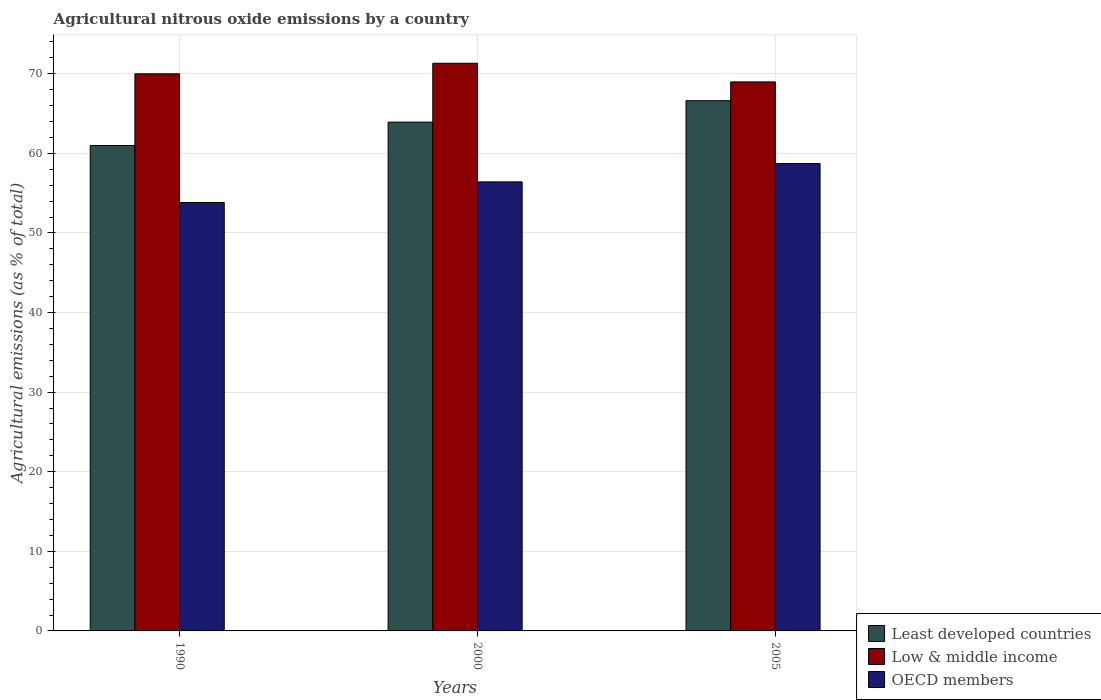How many groups of bars are there?
Ensure brevity in your answer.  3. Are the number of bars on each tick of the X-axis equal?
Keep it short and to the point. Yes. How many bars are there on the 2nd tick from the right?
Ensure brevity in your answer.  3. What is the label of the 2nd group of bars from the left?
Your answer should be compact. 2000. What is the amount of agricultural nitrous oxide emitted in Least developed countries in 1990?
Your answer should be compact. 60.99. Across all years, what is the maximum amount of agricultural nitrous oxide emitted in OECD members?
Offer a terse response. 58.73. Across all years, what is the minimum amount of agricultural nitrous oxide emitted in OECD members?
Provide a short and direct response. 53.83. What is the total amount of agricultural nitrous oxide emitted in OECD members in the graph?
Provide a short and direct response. 168.98. What is the difference between the amount of agricultural nitrous oxide emitted in Least developed countries in 1990 and that in 2000?
Provide a short and direct response. -2.94. What is the difference between the amount of agricultural nitrous oxide emitted in Least developed countries in 2000 and the amount of agricultural nitrous oxide emitted in OECD members in 1990?
Provide a short and direct response. 10.1. What is the average amount of agricultural nitrous oxide emitted in Low & middle income per year?
Provide a short and direct response. 70.1. In the year 2000, what is the difference between the amount of agricultural nitrous oxide emitted in Low & middle income and amount of agricultural nitrous oxide emitted in OECD members?
Give a very brief answer. 14.91. What is the ratio of the amount of agricultural nitrous oxide emitted in Least developed countries in 1990 to that in 2005?
Make the answer very short. 0.92. Is the amount of agricultural nitrous oxide emitted in Low & middle income in 1990 less than that in 2005?
Give a very brief answer. No. What is the difference between the highest and the second highest amount of agricultural nitrous oxide emitted in OECD members?
Provide a short and direct response. 2.31. What is the difference between the highest and the lowest amount of agricultural nitrous oxide emitted in Low & middle income?
Provide a short and direct response. 2.34. What does the 1st bar from the left in 2005 represents?
Provide a succinct answer. Least developed countries. What does the 3rd bar from the right in 2000 represents?
Provide a short and direct response. Least developed countries. Is it the case that in every year, the sum of the amount of agricultural nitrous oxide emitted in Least developed countries and amount of agricultural nitrous oxide emitted in OECD members is greater than the amount of agricultural nitrous oxide emitted in Low & middle income?
Ensure brevity in your answer.  Yes. How many bars are there?
Your response must be concise. 9. Does the graph contain any zero values?
Give a very brief answer. No. How are the legend labels stacked?
Ensure brevity in your answer.  Vertical. What is the title of the graph?
Provide a succinct answer. Agricultural nitrous oxide emissions by a country. What is the label or title of the Y-axis?
Your response must be concise. Agricultural emissions (as % of total). What is the Agricultural emissions (as % of total) in Least developed countries in 1990?
Your response must be concise. 60.99. What is the Agricultural emissions (as % of total) in Low & middle income in 1990?
Your answer should be compact. 70. What is the Agricultural emissions (as % of total) in OECD members in 1990?
Give a very brief answer. 53.83. What is the Agricultural emissions (as % of total) of Least developed countries in 2000?
Make the answer very short. 63.93. What is the Agricultural emissions (as % of total) of Low & middle income in 2000?
Give a very brief answer. 71.32. What is the Agricultural emissions (as % of total) of OECD members in 2000?
Provide a succinct answer. 56.42. What is the Agricultural emissions (as % of total) of Least developed countries in 2005?
Your answer should be compact. 66.62. What is the Agricultural emissions (as % of total) of Low & middle income in 2005?
Ensure brevity in your answer.  68.98. What is the Agricultural emissions (as % of total) in OECD members in 2005?
Give a very brief answer. 58.73. Across all years, what is the maximum Agricultural emissions (as % of total) of Least developed countries?
Your answer should be compact. 66.62. Across all years, what is the maximum Agricultural emissions (as % of total) in Low & middle income?
Provide a succinct answer. 71.32. Across all years, what is the maximum Agricultural emissions (as % of total) in OECD members?
Offer a terse response. 58.73. Across all years, what is the minimum Agricultural emissions (as % of total) in Least developed countries?
Offer a very short reply. 60.99. Across all years, what is the minimum Agricultural emissions (as % of total) in Low & middle income?
Provide a short and direct response. 68.98. Across all years, what is the minimum Agricultural emissions (as % of total) in OECD members?
Your answer should be compact. 53.83. What is the total Agricultural emissions (as % of total) in Least developed countries in the graph?
Provide a short and direct response. 191.53. What is the total Agricultural emissions (as % of total) of Low & middle income in the graph?
Your answer should be compact. 210.3. What is the total Agricultural emissions (as % of total) of OECD members in the graph?
Provide a short and direct response. 168.98. What is the difference between the Agricultural emissions (as % of total) in Least developed countries in 1990 and that in 2000?
Give a very brief answer. -2.94. What is the difference between the Agricultural emissions (as % of total) in Low & middle income in 1990 and that in 2000?
Make the answer very short. -1.33. What is the difference between the Agricultural emissions (as % of total) in OECD members in 1990 and that in 2000?
Give a very brief answer. -2.59. What is the difference between the Agricultural emissions (as % of total) of Least developed countries in 1990 and that in 2005?
Provide a short and direct response. -5.63. What is the difference between the Agricultural emissions (as % of total) in Low & middle income in 1990 and that in 2005?
Keep it short and to the point. 1.02. What is the difference between the Agricultural emissions (as % of total) of OECD members in 1990 and that in 2005?
Your answer should be compact. -4.9. What is the difference between the Agricultural emissions (as % of total) of Least developed countries in 2000 and that in 2005?
Make the answer very short. -2.69. What is the difference between the Agricultural emissions (as % of total) in Low & middle income in 2000 and that in 2005?
Your answer should be compact. 2.34. What is the difference between the Agricultural emissions (as % of total) in OECD members in 2000 and that in 2005?
Make the answer very short. -2.31. What is the difference between the Agricultural emissions (as % of total) in Least developed countries in 1990 and the Agricultural emissions (as % of total) in Low & middle income in 2000?
Offer a very short reply. -10.34. What is the difference between the Agricultural emissions (as % of total) in Least developed countries in 1990 and the Agricultural emissions (as % of total) in OECD members in 2000?
Your answer should be compact. 4.57. What is the difference between the Agricultural emissions (as % of total) in Low & middle income in 1990 and the Agricultural emissions (as % of total) in OECD members in 2000?
Offer a terse response. 13.58. What is the difference between the Agricultural emissions (as % of total) of Least developed countries in 1990 and the Agricultural emissions (as % of total) of Low & middle income in 2005?
Your answer should be very brief. -8. What is the difference between the Agricultural emissions (as % of total) of Least developed countries in 1990 and the Agricultural emissions (as % of total) of OECD members in 2005?
Keep it short and to the point. 2.26. What is the difference between the Agricultural emissions (as % of total) in Low & middle income in 1990 and the Agricultural emissions (as % of total) in OECD members in 2005?
Your answer should be compact. 11.27. What is the difference between the Agricultural emissions (as % of total) of Least developed countries in 2000 and the Agricultural emissions (as % of total) of Low & middle income in 2005?
Your answer should be very brief. -5.05. What is the difference between the Agricultural emissions (as % of total) in Least developed countries in 2000 and the Agricultural emissions (as % of total) in OECD members in 2005?
Make the answer very short. 5.2. What is the difference between the Agricultural emissions (as % of total) of Low & middle income in 2000 and the Agricultural emissions (as % of total) of OECD members in 2005?
Your response must be concise. 12.6. What is the average Agricultural emissions (as % of total) in Least developed countries per year?
Keep it short and to the point. 63.84. What is the average Agricultural emissions (as % of total) of Low & middle income per year?
Your response must be concise. 70.1. What is the average Agricultural emissions (as % of total) in OECD members per year?
Ensure brevity in your answer.  56.33. In the year 1990, what is the difference between the Agricultural emissions (as % of total) of Least developed countries and Agricultural emissions (as % of total) of Low & middle income?
Offer a very short reply. -9.01. In the year 1990, what is the difference between the Agricultural emissions (as % of total) of Least developed countries and Agricultural emissions (as % of total) of OECD members?
Offer a terse response. 7.15. In the year 1990, what is the difference between the Agricultural emissions (as % of total) in Low & middle income and Agricultural emissions (as % of total) in OECD members?
Offer a terse response. 16.17. In the year 2000, what is the difference between the Agricultural emissions (as % of total) in Least developed countries and Agricultural emissions (as % of total) in Low & middle income?
Ensure brevity in your answer.  -7.39. In the year 2000, what is the difference between the Agricultural emissions (as % of total) of Least developed countries and Agricultural emissions (as % of total) of OECD members?
Offer a terse response. 7.51. In the year 2000, what is the difference between the Agricultural emissions (as % of total) in Low & middle income and Agricultural emissions (as % of total) in OECD members?
Your answer should be very brief. 14.91. In the year 2005, what is the difference between the Agricultural emissions (as % of total) in Least developed countries and Agricultural emissions (as % of total) in Low & middle income?
Your answer should be very brief. -2.36. In the year 2005, what is the difference between the Agricultural emissions (as % of total) in Least developed countries and Agricultural emissions (as % of total) in OECD members?
Provide a short and direct response. 7.89. In the year 2005, what is the difference between the Agricultural emissions (as % of total) in Low & middle income and Agricultural emissions (as % of total) in OECD members?
Give a very brief answer. 10.25. What is the ratio of the Agricultural emissions (as % of total) of Least developed countries in 1990 to that in 2000?
Keep it short and to the point. 0.95. What is the ratio of the Agricultural emissions (as % of total) in Low & middle income in 1990 to that in 2000?
Your response must be concise. 0.98. What is the ratio of the Agricultural emissions (as % of total) of OECD members in 1990 to that in 2000?
Your response must be concise. 0.95. What is the ratio of the Agricultural emissions (as % of total) of Least developed countries in 1990 to that in 2005?
Provide a short and direct response. 0.92. What is the ratio of the Agricultural emissions (as % of total) of Low & middle income in 1990 to that in 2005?
Ensure brevity in your answer.  1.01. What is the ratio of the Agricultural emissions (as % of total) of OECD members in 1990 to that in 2005?
Ensure brevity in your answer.  0.92. What is the ratio of the Agricultural emissions (as % of total) in Least developed countries in 2000 to that in 2005?
Provide a short and direct response. 0.96. What is the ratio of the Agricultural emissions (as % of total) in Low & middle income in 2000 to that in 2005?
Your answer should be compact. 1.03. What is the ratio of the Agricultural emissions (as % of total) of OECD members in 2000 to that in 2005?
Offer a very short reply. 0.96. What is the difference between the highest and the second highest Agricultural emissions (as % of total) of Least developed countries?
Offer a very short reply. 2.69. What is the difference between the highest and the second highest Agricultural emissions (as % of total) of Low & middle income?
Make the answer very short. 1.33. What is the difference between the highest and the second highest Agricultural emissions (as % of total) in OECD members?
Make the answer very short. 2.31. What is the difference between the highest and the lowest Agricultural emissions (as % of total) of Least developed countries?
Your response must be concise. 5.63. What is the difference between the highest and the lowest Agricultural emissions (as % of total) of Low & middle income?
Provide a short and direct response. 2.34. What is the difference between the highest and the lowest Agricultural emissions (as % of total) of OECD members?
Give a very brief answer. 4.9. 